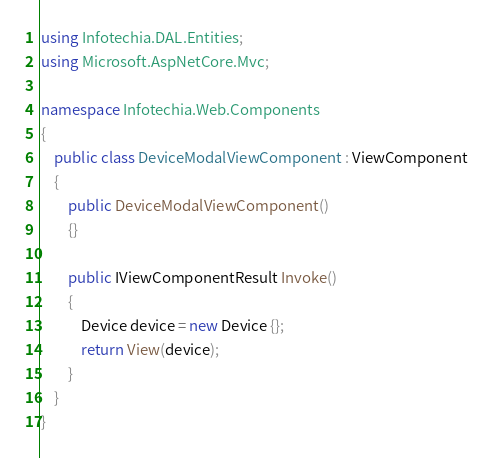<code> <loc_0><loc_0><loc_500><loc_500><_C#_>using Infotechia.DAL.Entities;
using Microsoft.AspNetCore.Mvc;

namespace Infotechia.Web.Components
{
    public class DeviceModalViewComponent : ViewComponent
    {
        public DeviceModalViewComponent() 
        {}

        public IViewComponentResult Invoke()
        {
            Device device = new Device {};
            return View(device);
        }
    }
}</code> 